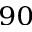<formula> <loc_0><loc_0><loc_500><loc_500>_ { 9 0 }</formula> 